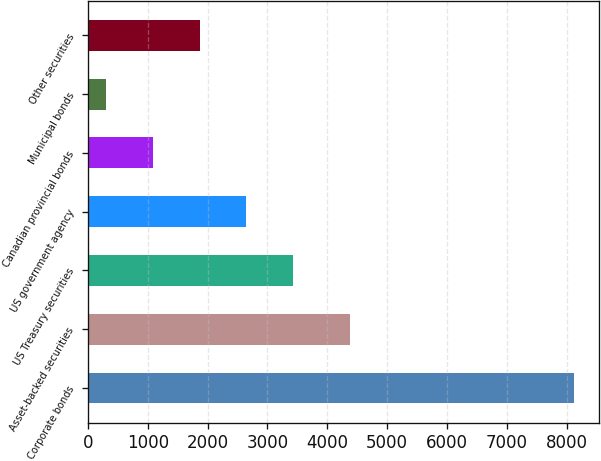<chart> <loc_0><loc_0><loc_500><loc_500><bar_chart><fcel>Corporate bonds<fcel>Asset-backed securities<fcel>US Treasury securities<fcel>US government agency<fcel>Canadian provincial bonds<fcel>Municipal bonds<fcel>Other securities<nl><fcel>8127.1<fcel>4383.6<fcel>3431.92<fcel>2649.39<fcel>1084.33<fcel>301.8<fcel>1866.86<nl></chart> 